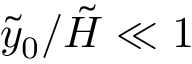Convert formula to latex. <formula><loc_0><loc_0><loc_500><loc_500>{ \tilde { y } _ { 0 } } / { \tilde { H } } \ll 1</formula> 